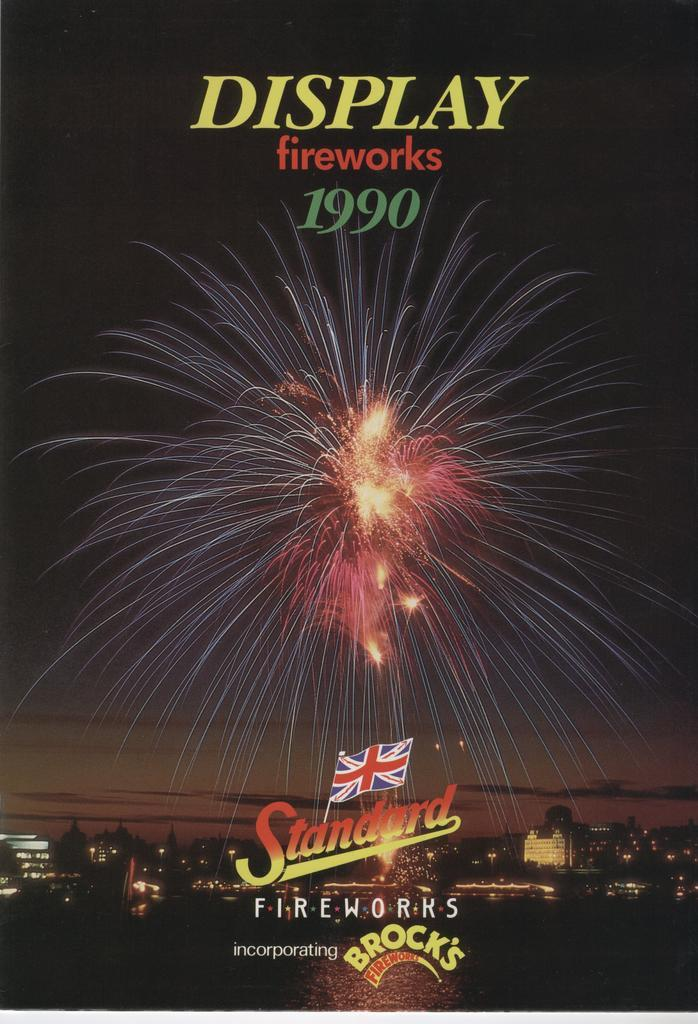<image>
Share a concise interpretation of the image provided. A poster for the fireworks display in 1990 is sponsored by Brock's. 